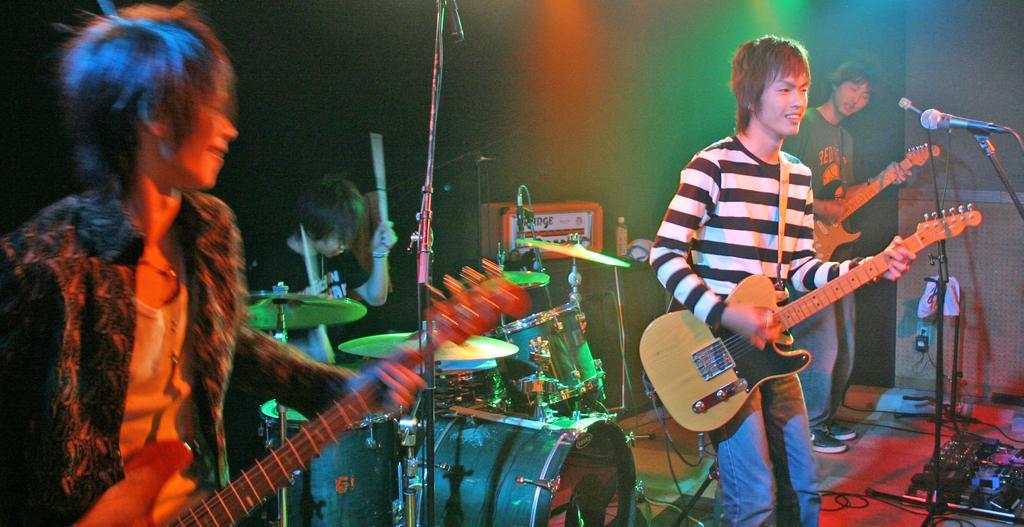Could you give a brief overview of what you see in this image? In this image there are four man three men are standing holding the guitar,playing the guitar in front of the man there is a microphone. This man is sitting and playing the drums. 